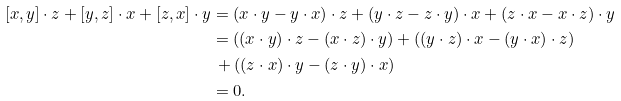<formula> <loc_0><loc_0><loc_500><loc_500>[ x , y ] \cdot z + [ y , z ] \cdot x + [ z , x ] \cdot y & = ( x \cdot y - y \cdot x ) \cdot z + ( y \cdot z - z \cdot y ) \cdot x + ( z \cdot x - x \cdot z ) \cdot y \\ & = ( ( x \cdot y ) \cdot z - ( x \cdot z ) \cdot y ) + ( ( y \cdot z ) \cdot x - ( y \cdot x ) \cdot z ) \\ & \, + ( ( z \cdot x ) \cdot y - ( z \cdot y ) \cdot x ) \\ & = 0 .</formula> 